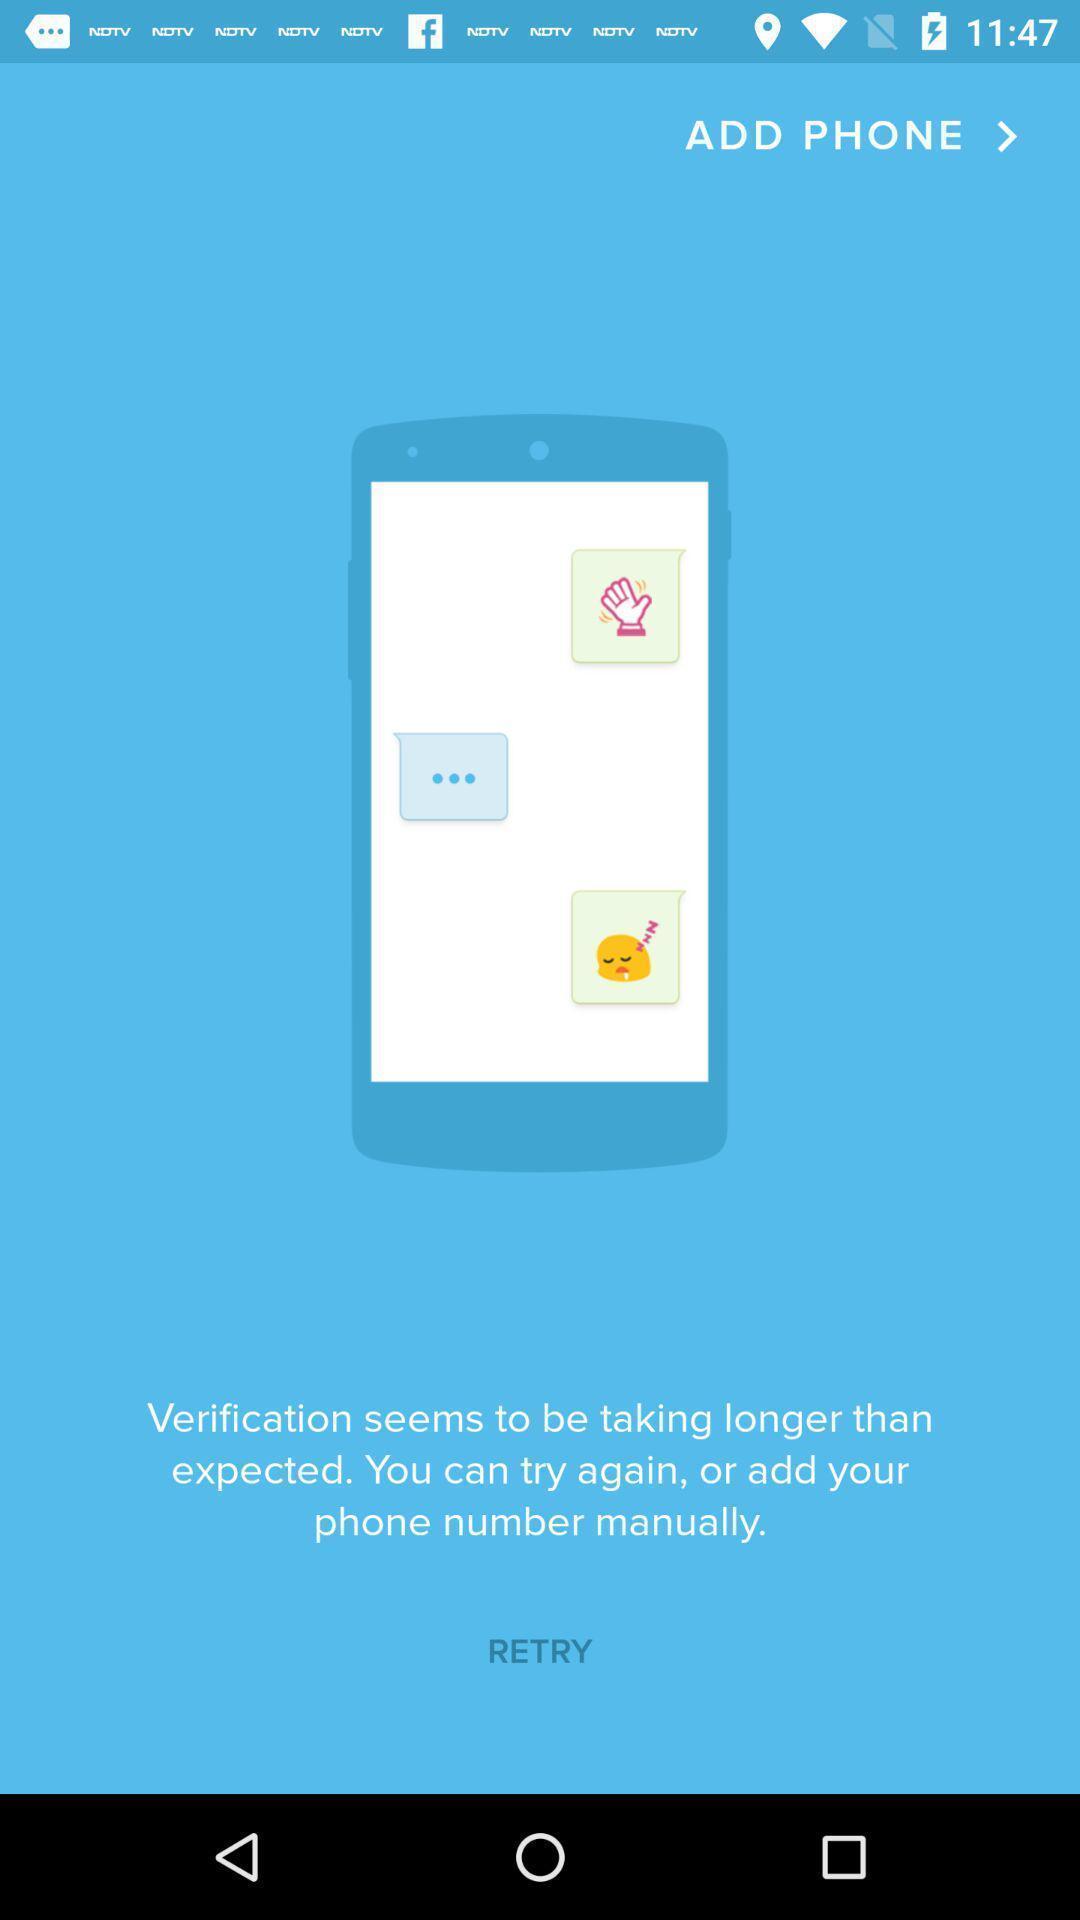Describe the key features of this screenshot. Welcome page. 